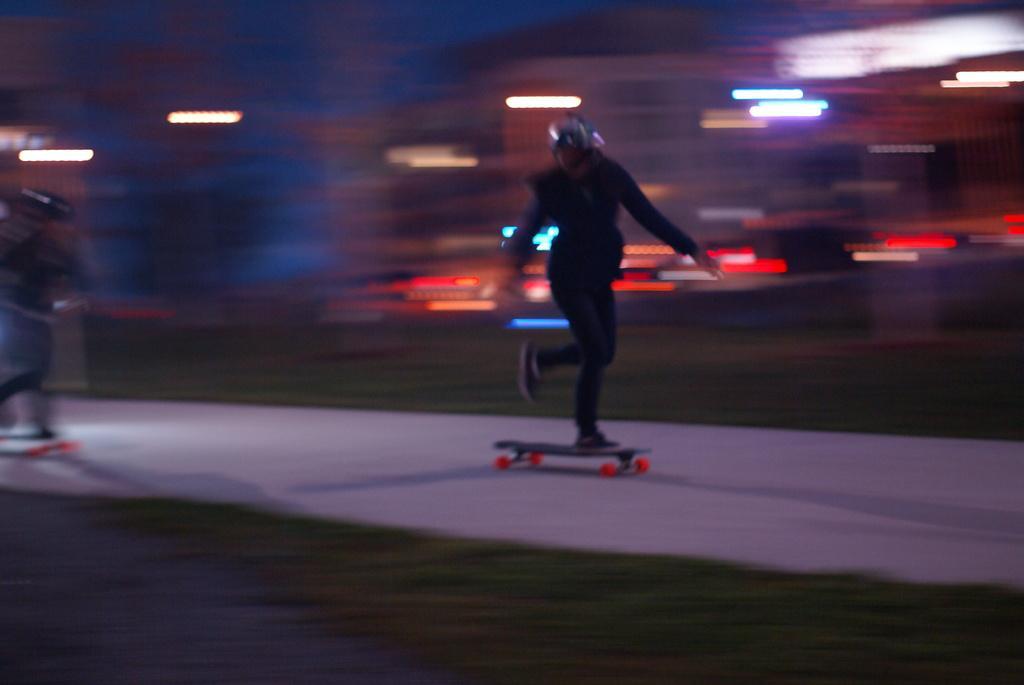Can you describe this image briefly? In this image, I can see a person standing on a skateboard. This looks like a pathway. The background looks blurry. I can see the lights. On the left side of the image, I think there's another person standing. 